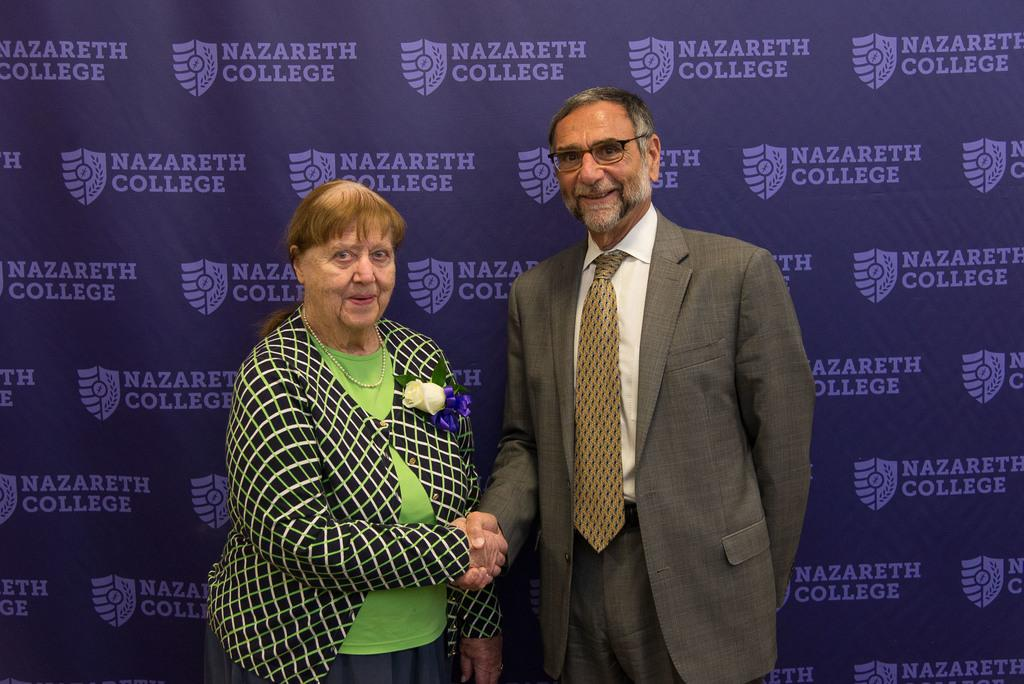Who is present in the image? There is a woman and a man in the image. What are the woman and man doing in the image? The woman and man are shaking hands in the image. What expressions do the woman and man have in the image? Both the woman and man are smiling in the image. What can be seen in the background of the image? There is a banner with text in the background of the image. What type of comb is the man using to style his hair in the image? There is no comb visible in the image, and the man's hair is not being styled. Can you hear the whistle that the woman is playing in the image? There is no whistle present in the image, and the woman is not playing any musical instrument. 